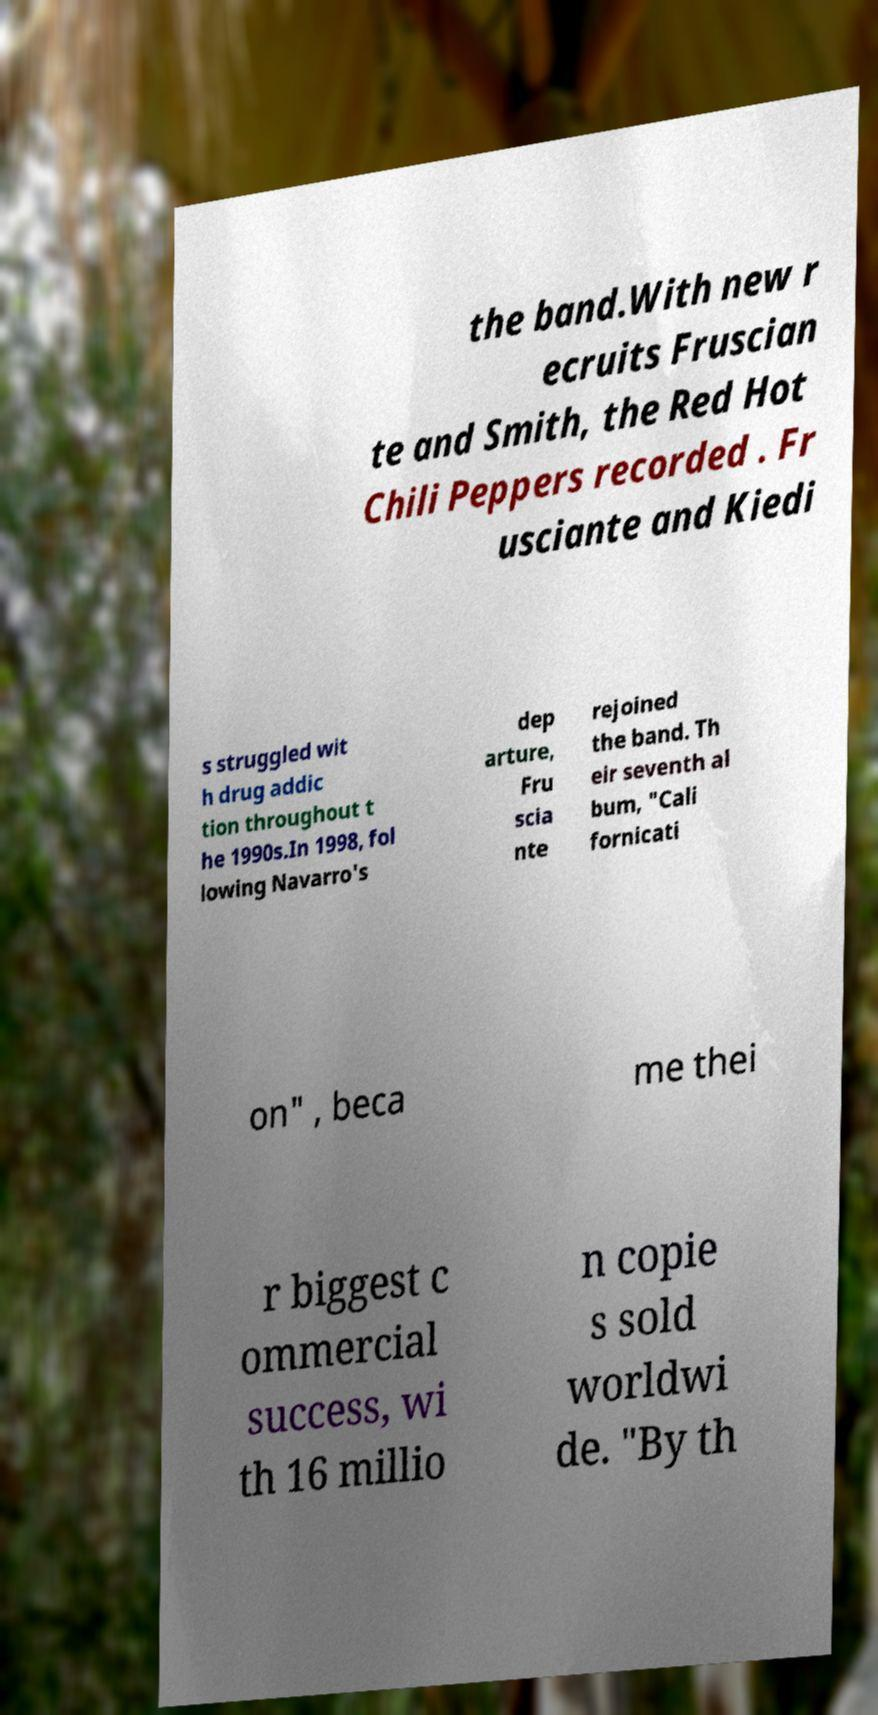What messages or text are displayed in this image? I need them in a readable, typed format. the band.With new r ecruits Fruscian te and Smith, the Red Hot Chili Peppers recorded . Fr usciante and Kiedi s struggled wit h drug addic tion throughout t he 1990s.In 1998, fol lowing Navarro's dep arture, Fru scia nte rejoined the band. Th eir seventh al bum, "Cali fornicati on" , beca me thei r biggest c ommercial success, wi th 16 millio n copie s sold worldwi de. "By th 